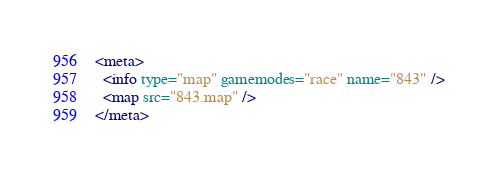<code> <loc_0><loc_0><loc_500><loc_500><_XML_><meta>
  <info type="map" gamemodes="race" name="843" />
  <map src="843.map" />
</meta></code> 